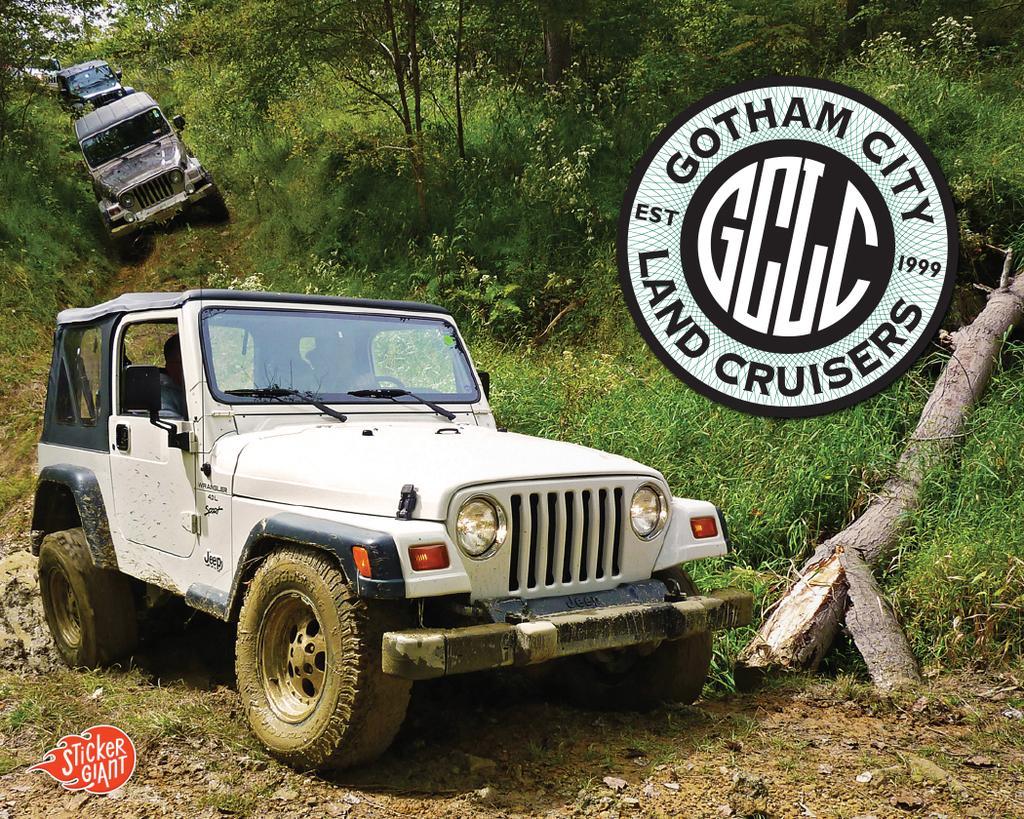Could you give a brief overview of what you see in this image? In this image I can see few vehicles in different color. Back I can see few trees,green grass and stamp in front. 